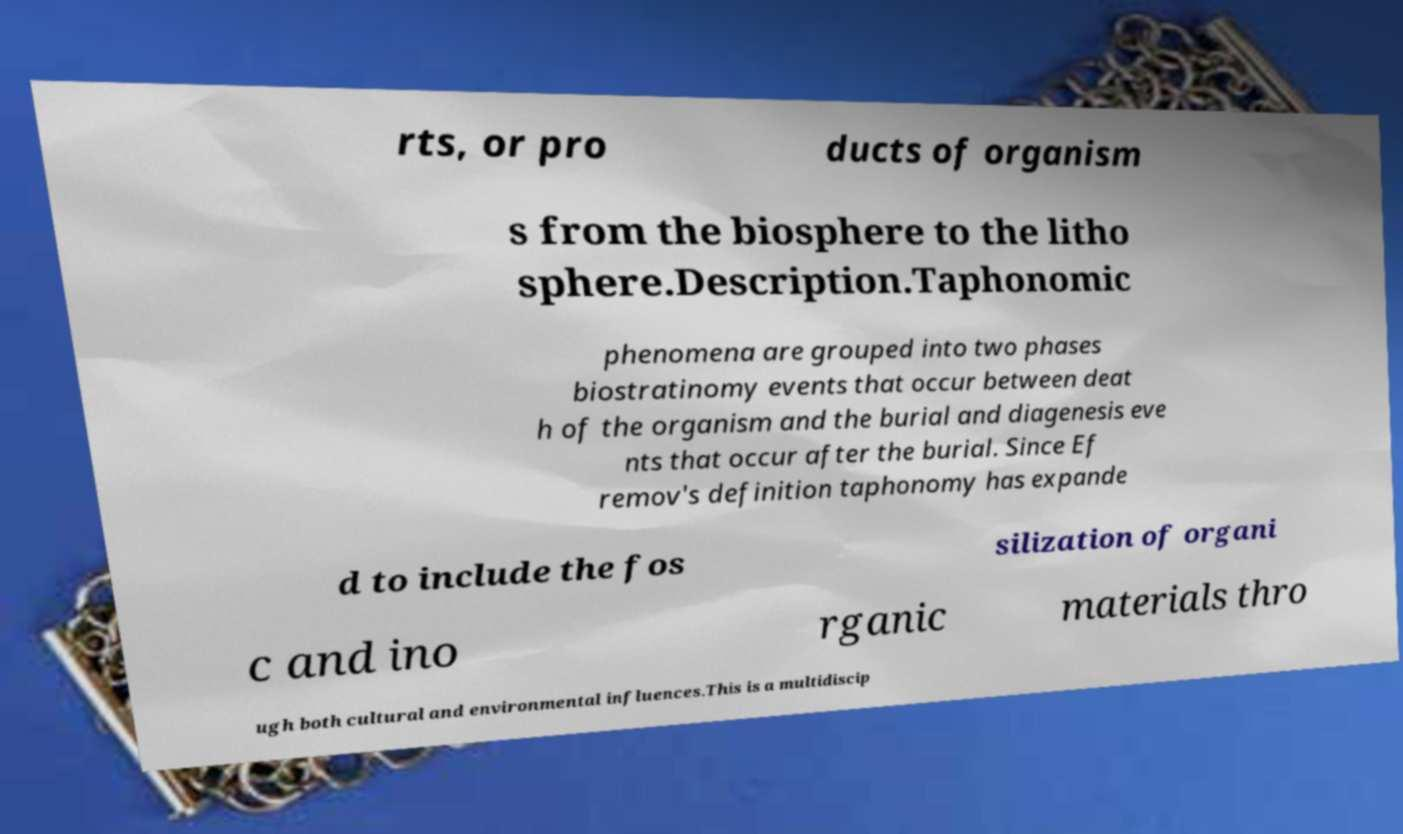Could you extract and type out the text from this image? rts, or pro ducts of organism s from the biosphere to the litho sphere.Description.Taphonomic phenomena are grouped into two phases biostratinomy events that occur between deat h of the organism and the burial and diagenesis eve nts that occur after the burial. Since Ef remov's definition taphonomy has expande d to include the fos silization of organi c and ino rganic materials thro ugh both cultural and environmental influences.This is a multidiscip 